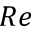Convert formula to latex. <formula><loc_0><loc_0><loc_500><loc_500>R e</formula> 